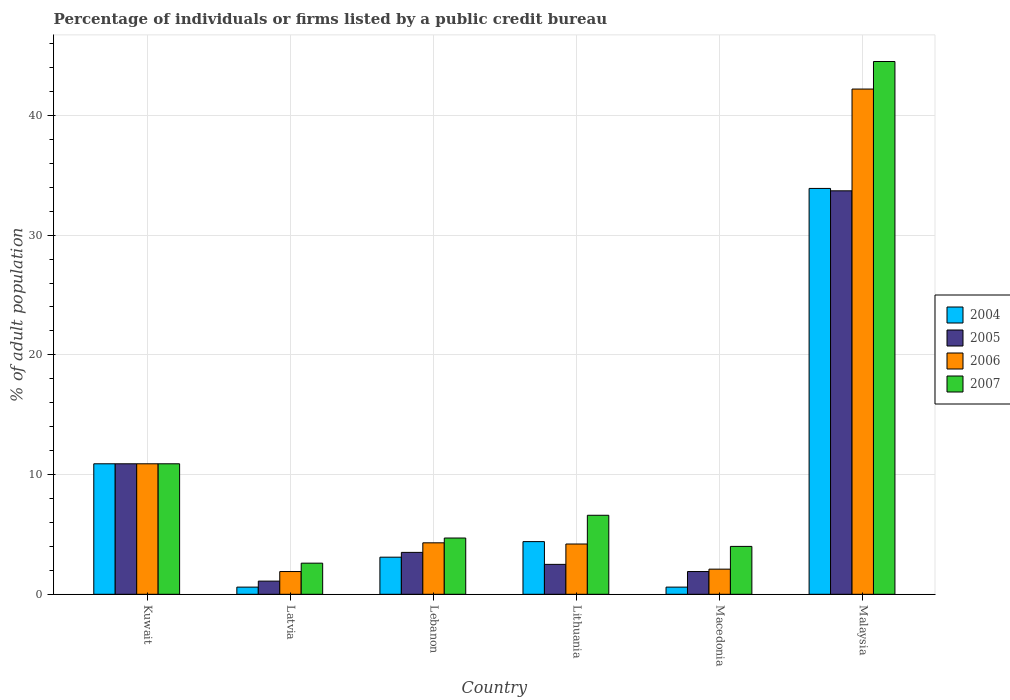How many different coloured bars are there?
Offer a very short reply. 4. What is the label of the 3rd group of bars from the left?
Keep it short and to the point. Lebanon. What is the percentage of population listed by a public credit bureau in 2007 in Kuwait?
Keep it short and to the point. 10.9. Across all countries, what is the maximum percentage of population listed by a public credit bureau in 2007?
Offer a very short reply. 44.5. In which country was the percentage of population listed by a public credit bureau in 2005 maximum?
Provide a short and direct response. Malaysia. In which country was the percentage of population listed by a public credit bureau in 2005 minimum?
Provide a succinct answer. Latvia. What is the total percentage of population listed by a public credit bureau in 2007 in the graph?
Provide a short and direct response. 73.3. What is the difference between the percentage of population listed by a public credit bureau in 2005 in Latvia and that in Macedonia?
Give a very brief answer. -0.8. What is the average percentage of population listed by a public credit bureau in 2004 per country?
Offer a terse response. 8.92. What is the difference between the percentage of population listed by a public credit bureau of/in 2004 and percentage of population listed by a public credit bureau of/in 2005 in Lithuania?
Provide a short and direct response. 1.9. What is the ratio of the percentage of population listed by a public credit bureau in 2007 in Latvia to that in Malaysia?
Give a very brief answer. 0.06. Is the difference between the percentage of population listed by a public credit bureau in 2004 in Lithuania and Macedonia greater than the difference between the percentage of population listed by a public credit bureau in 2005 in Lithuania and Macedonia?
Your answer should be very brief. Yes. What is the difference between the highest and the second highest percentage of population listed by a public credit bureau in 2007?
Provide a short and direct response. -33.6. What is the difference between the highest and the lowest percentage of population listed by a public credit bureau in 2006?
Your answer should be compact. 40.3. Is the sum of the percentage of population listed by a public credit bureau in 2004 in Latvia and Macedonia greater than the maximum percentage of population listed by a public credit bureau in 2007 across all countries?
Offer a terse response. No. Is it the case that in every country, the sum of the percentage of population listed by a public credit bureau in 2004 and percentage of population listed by a public credit bureau in 2006 is greater than the sum of percentage of population listed by a public credit bureau in 2007 and percentage of population listed by a public credit bureau in 2005?
Ensure brevity in your answer.  No. What does the 4th bar from the left in Malaysia represents?
Keep it short and to the point. 2007. Is it the case that in every country, the sum of the percentage of population listed by a public credit bureau in 2004 and percentage of population listed by a public credit bureau in 2006 is greater than the percentage of population listed by a public credit bureau in 2007?
Provide a succinct answer. No. How many bars are there?
Offer a very short reply. 24. How many countries are there in the graph?
Provide a succinct answer. 6. Are the values on the major ticks of Y-axis written in scientific E-notation?
Provide a short and direct response. No. How are the legend labels stacked?
Offer a very short reply. Vertical. What is the title of the graph?
Keep it short and to the point. Percentage of individuals or firms listed by a public credit bureau. Does "1987" appear as one of the legend labels in the graph?
Provide a succinct answer. No. What is the label or title of the Y-axis?
Your answer should be compact. % of adult population. What is the % of adult population of 2004 in Kuwait?
Give a very brief answer. 10.9. What is the % of adult population in 2005 in Kuwait?
Offer a terse response. 10.9. What is the % of adult population in 2007 in Kuwait?
Ensure brevity in your answer.  10.9. What is the % of adult population in 2004 in Latvia?
Give a very brief answer. 0.6. What is the % of adult population of 2006 in Latvia?
Ensure brevity in your answer.  1.9. What is the % of adult population of 2004 in Lebanon?
Make the answer very short. 3.1. What is the % of adult population in 2005 in Lithuania?
Keep it short and to the point. 2.5. What is the % of adult population of 2006 in Lithuania?
Your answer should be compact. 4.2. What is the % of adult population in 2004 in Macedonia?
Provide a short and direct response. 0.6. What is the % of adult population in 2007 in Macedonia?
Provide a short and direct response. 4. What is the % of adult population of 2004 in Malaysia?
Give a very brief answer. 33.9. What is the % of adult population in 2005 in Malaysia?
Your answer should be very brief. 33.7. What is the % of adult population in 2006 in Malaysia?
Make the answer very short. 42.2. What is the % of adult population of 2007 in Malaysia?
Ensure brevity in your answer.  44.5. Across all countries, what is the maximum % of adult population in 2004?
Make the answer very short. 33.9. Across all countries, what is the maximum % of adult population of 2005?
Offer a very short reply. 33.7. Across all countries, what is the maximum % of adult population in 2006?
Keep it short and to the point. 42.2. Across all countries, what is the maximum % of adult population of 2007?
Give a very brief answer. 44.5. Across all countries, what is the minimum % of adult population in 2005?
Provide a short and direct response. 1.1. Across all countries, what is the minimum % of adult population in 2006?
Your answer should be very brief. 1.9. What is the total % of adult population of 2004 in the graph?
Offer a very short reply. 53.5. What is the total % of adult population of 2005 in the graph?
Offer a very short reply. 53.6. What is the total % of adult population in 2006 in the graph?
Keep it short and to the point. 65.6. What is the total % of adult population of 2007 in the graph?
Give a very brief answer. 73.3. What is the difference between the % of adult population of 2006 in Kuwait and that in Latvia?
Offer a terse response. 9. What is the difference between the % of adult population of 2007 in Kuwait and that in Latvia?
Provide a short and direct response. 8.3. What is the difference between the % of adult population of 2007 in Kuwait and that in Lebanon?
Ensure brevity in your answer.  6.2. What is the difference between the % of adult population of 2005 in Kuwait and that in Lithuania?
Your response must be concise. 8.4. What is the difference between the % of adult population of 2007 in Kuwait and that in Lithuania?
Your answer should be compact. 4.3. What is the difference between the % of adult population in 2004 in Kuwait and that in Macedonia?
Give a very brief answer. 10.3. What is the difference between the % of adult population of 2006 in Kuwait and that in Macedonia?
Offer a very short reply. 8.8. What is the difference between the % of adult population in 2004 in Kuwait and that in Malaysia?
Ensure brevity in your answer.  -23. What is the difference between the % of adult population in 2005 in Kuwait and that in Malaysia?
Keep it short and to the point. -22.8. What is the difference between the % of adult population of 2006 in Kuwait and that in Malaysia?
Offer a very short reply. -31.3. What is the difference between the % of adult population in 2007 in Kuwait and that in Malaysia?
Your answer should be very brief. -33.6. What is the difference between the % of adult population of 2004 in Latvia and that in Lebanon?
Offer a terse response. -2.5. What is the difference between the % of adult population of 2005 in Latvia and that in Lebanon?
Provide a short and direct response. -2.4. What is the difference between the % of adult population in 2005 in Latvia and that in Lithuania?
Offer a very short reply. -1.4. What is the difference between the % of adult population of 2006 in Latvia and that in Lithuania?
Provide a succinct answer. -2.3. What is the difference between the % of adult population of 2007 in Latvia and that in Lithuania?
Ensure brevity in your answer.  -4. What is the difference between the % of adult population of 2004 in Latvia and that in Macedonia?
Your answer should be compact. 0. What is the difference between the % of adult population of 2005 in Latvia and that in Macedonia?
Offer a terse response. -0.8. What is the difference between the % of adult population in 2004 in Latvia and that in Malaysia?
Keep it short and to the point. -33.3. What is the difference between the % of adult population of 2005 in Latvia and that in Malaysia?
Make the answer very short. -32.6. What is the difference between the % of adult population in 2006 in Latvia and that in Malaysia?
Give a very brief answer. -40.3. What is the difference between the % of adult population in 2007 in Latvia and that in Malaysia?
Give a very brief answer. -41.9. What is the difference between the % of adult population of 2004 in Lebanon and that in Lithuania?
Provide a short and direct response. -1.3. What is the difference between the % of adult population in 2005 in Lebanon and that in Lithuania?
Offer a very short reply. 1. What is the difference between the % of adult population in 2004 in Lebanon and that in Macedonia?
Offer a terse response. 2.5. What is the difference between the % of adult population in 2006 in Lebanon and that in Macedonia?
Your response must be concise. 2.2. What is the difference between the % of adult population of 2007 in Lebanon and that in Macedonia?
Give a very brief answer. 0.7. What is the difference between the % of adult population in 2004 in Lebanon and that in Malaysia?
Ensure brevity in your answer.  -30.8. What is the difference between the % of adult population in 2005 in Lebanon and that in Malaysia?
Your response must be concise. -30.2. What is the difference between the % of adult population of 2006 in Lebanon and that in Malaysia?
Provide a succinct answer. -37.9. What is the difference between the % of adult population of 2007 in Lebanon and that in Malaysia?
Provide a succinct answer. -39.8. What is the difference between the % of adult population of 2005 in Lithuania and that in Macedonia?
Your response must be concise. 0.6. What is the difference between the % of adult population in 2004 in Lithuania and that in Malaysia?
Your response must be concise. -29.5. What is the difference between the % of adult population of 2005 in Lithuania and that in Malaysia?
Your answer should be compact. -31.2. What is the difference between the % of adult population in 2006 in Lithuania and that in Malaysia?
Ensure brevity in your answer.  -38. What is the difference between the % of adult population of 2007 in Lithuania and that in Malaysia?
Make the answer very short. -37.9. What is the difference between the % of adult population in 2004 in Macedonia and that in Malaysia?
Your answer should be very brief. -33.3. What is the difference between the % of adult population of 2005 in Macedonia and that in Malaysia?
Give a very brief answer. -31.8. What is the difference between the % of adult population of 2006 in Macedonia and that in Malaysia?
Provide a succinct answer. -40.1. What is the difference between the % of adult population of 2007 in Macedonia and that in Malaysia?
Give a very brief answer. -40.5. What is the difference between the % of adult population of 2004 in Kuwait and the % of adult population of 2005 in Latvia?
Provide a succinct answer. 9.8. What is the difference between the % of adult population in 2004 in Kuwait and the % of adult population in 2006 in Latvia?
Your answer should be compact. 9. What is the difference between the % of adult population of 2005 in Kuwait and the % of adult population of 2007 in Latvia?
Your response must be concise. 8.3. What is the difference between the % of adult population in 2004 in Kuwait and the % of adult population in 2005 in Lebanon?
Ensure brevity in your answer.  7.4. What is the difference between the % of adult population in 2005 in Kuwait and the % of adult population in 2006 in Lebanon?
Make the answer very short. 6.6. What is the difference between the % of adult population of 2005 in Kuwait and the % of adult population of 2007 in Lebanon?
Ensure brevity in your answer.  6.2. What is the difference between the % of adult population in 2006 in Kuwait and the % of adult population in 2007 in Lebanon?
Offer a very short reply. 6.2. What is the difference between the % of adult population of 2004 in Kuwait and the % of adult population of 2005 in Lithuania?
Offer a terse response. 8.4. What is the difference between the % of adult population of 2004 in Kuwait and the % of adult population of 2006 in Lithuania?
Ensure brevity in your answer.  6.7. What is the difference between the % of adult population of 2004 in Kuwait and the % of adult population of 2007 in Lithuania?
Give a very brief answer. 4.3. What is the difference between the % of adult population of 2005 in Kuwait and the % of adult population of 2006 in Lithuania?
Your answer should be compact. 6.7. What is the difference between the % of adult population of 2004 in Kuwait and the % of adult population of 2007 in Macedonia?
Offer a terse response. 6.9. What is the difference between the % of adult population of 2005 in Kuwait and the % of adult population of 2006 in Macedonia?
Ensure brevity in your answer.  8.8. What is the difference between the % of adult population in 2006 in Kuwait and the % of adult population in 2007 in Macedonia?
Provide a short and direct response. 6.9. What is the difference between the % of adult population of 2004 in Kuwait and the % of adult population of 2005 in Malaysia?
Give a very brief answer. -22.8. What is the difference between the % of adult population of 2004 in Kuwait and the % of adult population of 2006 in Malaysia?
Give a very brief answer. -31.3. What is the difference between the % of adult population of 2004 in Kuwait and the % of adult population of 2007 in Malaysia?
Your answer should be compact. -33.6. What is the difference between the % of adult population of 2005 in Kuwait and the % of adult population of 2006 in Malaysia?
Offer a very short reply. -31.3. What is the difference between the % of adult population in 2005 in Kuwait and the % of adult population in 2007 in Malaysia?
Offer a very short reply. -33.6. What is the difference between the % of adult population in 2006 in Kuwait and the % of adult population in 2007 in Malaysia?
Offer a terse response. -33.6. What is the difference between the % of adult population in 2004 in Latvia and the % of adult population in 2007 in Lebanon?
Your response must be concise. -4.1. What is the difference between the % of adult population in 2005 in Latvia and the % of adult population in 2006 in Lithuania?
Offer a terse response. -3.1. What is the difference between the % of adult population in 2005 in Latvia and the % of adult population in 2007 in Lithuania?
Ensure brevity in your answer.  -5.5. What is the difference between the % of adult population of 2004 in Latvia and the % of adult population of 2005 in Macedonia?
Make the answer very short. -1.3. What is the difference between the % of adult population of 2004 in Latvia and the % of adult population of 2007 in Macedonia?
Keep it short and to the point. -3.4. What is the difference between the % of adult population in 2006 in Latvia and the % of adult population in 2007 in Macedonia?
Offer a very short reply. -2.1. What is the difference between the % of adult population in 2004 in Latvia and the % of adult population in 2005 in Malaysia?
Give a very brief answer. -33.1. What is the difference between the % of adult population in 2004 in Latvia and the % of adult population in 2006 in Malaysia?
Keep it short and to the point. -41.6. What is the difference between the % of adult population in 2004 in Latvia and the % of adult population in 2007 in Malaysia?
Offer a terse response. -43.9. What is the difference between the % of adult population of 2005 in Latvia and the % of adult population of 2006 in Malaysia?
Give a very brief answer. -41.1. What is the difference between the % of adult population in 2005 in Latvia and the % of adult population in 2007 in Malaysia?
Provide a short and direct response. -43.4. What is the difference between the % of adult population of 2006 in Latvia and the % of adult population of 2007 in Malaysia?
Provide a succinct answer. -42.6. What is the difference between the % of adult population of 2004 in Lebanon and the % of adult population of 2005 in Lithuania?
Your answer should be compact. 0.6. What is the difference between the % of adult population in 2004 in Lebanon and the % of adult population in 2006 in Lithuania?
Your response must be concise. -1.1. What is the difference between the % of adult population in 2005 in Lebanon and the % of adult population in 2006 in Lithuania?
Your answer should be compact. -0.7. What is the difference between the % of adult population of 2005 in Lebanon and the % of adult population of 2007 in Lithuania?
Give a very brief answer. -3.1. What is the difference between the % of adult population of 2004 in Lebanon and the % of adult population of 2006 in Macedonia?
Ensure brevity in your answer.  1. What is the difference between the % of adult population of 2005 in Lebanon and the % of adult population of 2006 in Macedonia?
Provide a short and direct response. 1.4. What is the difference between the % of adult population of 2005 in Lebanon and the % of adult population of 2007 in Macedonia?
Provide a succinct answer. -0.5. What is the difference between the % of adult population of 2006 in Lebanon and the % of adult population of 2007 in Macedonia?
Ensure brevity in your answer.  0.3. What is the difference between the % of adult population of 2004 in Lebanon and the % of adult population of 2005 in Malaysia?
Offer a terse response. -30.6. What is the difference between the % of adult population in 2004 in Lebanon and the % of adult population in 2006 in Malaysia?
Your answer should be very brief. -39.1. What is the difference between the % of adult population in 2004 in Lebanon and the % of adult population in 2007 in Malaysia?
Make the answer very short. -41.4. What is the difference between the % of adult population of 2005 in Lebanon and the % of adult population of 2006 in Malaysia?
Your answer should be compact. -38.7. What is the difference between the % of adult population of 2005 in Lebanon and the % of adult population of 2007 in Malaysia?
Your answer should be very brief. -41. What is the difference between the % of adult population of 2006 in Lebanon and the % of adult population of 2007 in Malaysia?
Provide a short and direct response. -40.2. What is the difference between the % of adult population in 2004 in Lithuania and the % of adult population in 2006 in Macedonia?
Your answer should be very brief. 2.3. What is the difference between the % of adult population of 2005 in Lithuania and the % of adult population of 2007 in Macedonia?
Ensure brevity in your answer.  -1.5. What is the difference between the % of adult population in 2006 in Lithuania and the % of adult population in 2007 in Macedonia?
Ensure brevity in your answer.  0.2. What is the difference between the % of adult population in 2004 in Lithuania and the % of adult population in 2005 in Malaysia?
Your response must be concise. -29.3. What is the difference between the % of adult population in 2004 in Lithuania and the % of adult population in 2006 in Malaysia?
Make the answer very short. -37.8. What is the difference between the % of adult population in 2004 in Lithuania and the % of adult population in 2007 in Malaysia?
Give a very brief answer. -40.1. What is the difference between the % of adult population of 2005 in Lithuania and the % of adult population of 2006 in Malaysia?
Offer a very short reply. -39.7. What is the difference between the % of adult population in 2005 in Lithuania and the % of adult population in 2007 in Malaysia?
Provide a short and direct response. -42. What is the difference between the % of adult population in 2006 in Lithuania and the % of adult population in 2007 in Malaysia?
Offer a very short reply. -40.3. What is the difference between the % of adult population in 2004 in Macedonia and the % of adult population in 2005 in Malaysia?
Make the answer very short. -33.1. What is the difference between the % of adult population in 2004 in Macedonia and the % of adult population in 2006 in Malaysia?
Give a very brief answer. -41.6. What is the difference between the % of adult population of 2004 in Macedonia and the % of adult population of 2007 in Malaysia?
Give a very brief answer. -43.9. What is the difference between the % of adult population of 2005 in Macedonia and the % of adult population of 2006 in Malaysia?
Offer a very short reply. -40.3. What is the difference between the % of adult population of 2005 in Macedonia and the % of adult population of 2007 in Malaysia?
Provide a succinct answer. -42.6. What is the difference between the % of adult population in 2006 in Macedonia and the % of adult population in 2007 in Malaysia?
Ensure brevity in your answer.  -42.4. What is the average % of adult population of 2004 per country?
Give a very brief answer. 8.92. What is the average % of adult population in 2005 per country?
Provide a short and direct response. 8.93. What is the average % of adult population of 2006 per country?
Your answer should be very brief. 10.93. What is the average % of adult population of 2007 per country?
Provide a short and direct response. 12.22. What is the difference between the % of adult population of 2004 and % of adult population of 2005 in Kuwait?
Your answer should be compact. 0. What is the difference between the % of adult population of 2005 and % of adult population of 2007 in Kuwait?
Ensure brevity in your answer.  0. What is the difference between the % of adult population of 2006 and % of adult population of 2007 in Kuwait?
Offer a terse response. 0. What is the difference between the % of adult population in 2004 and % of adult population in 2007 in Latvia?
Make the answer very short. -2. What is the difference between the % of adult population in 2005 and % of adult population in 2007 in Latvia?
Offer a very short reply. -1.5. What is the difference between the % of adult population in 2004 and % of adult population in 2005 in Lebanon?
Your response must be concise. -0.4. What is the difference between the % of adult population of 2004 and % of adult population of 2006 in Lebanon?
Provide a succinct answer. -1.2. What is the difference between the % of adult population of 2004 and % of adult population of 2007 in Lebanon?
Keep it short and to the point. -1.6. What is the difference between the % of adult population of 2005 and % of adult population of 2006 in Lebanon?
Your answer should be compact. -0.8. What is the difference between the % of adult population of 2004 and % of adult population of 2007 in Lithuania?
Your response must be concise. -2.2. What is the difference between the % of adult population of 2005 and % of adult population of 2006 in Lithuania?
Give a very brief answer. -1.7. What is the difference between the % of adult population in 2006 and % of adult population in 2007 in Lithuania?
Make the answer very short. -2.4. What is the difference between the % of adult population in 2004 and % of adult population in 2005 in Macedonia?
Offer a terse response. -1.3. What is the difference between the % of adult population in 2004 and % of adult population in 2006 in Macedonia?
Your answer should be very brief. -1.5. What is the difference between the % of adult population in 2005 and % of adult population in 2006 in Macedonia?
Keep it short and to the point. -0.2. What is the difference between the % of adult population in 2006 and % of adult population in 2007 in Macedonia?
Offer a terse response. -1.9. What is the difference between the % of adult population of 2004 and % of adult population of 2007 in Malaysia?
Make the answer very short. -10.6. What is the difference between the % of adult population of 2006 and % of adult population of 2007 in Malaysia?
Your answer should be compact. -2.3. What is the ratio of the % of adult population of 2004 in Kuwait to that in Latvia?
Offer a very short reply. 18.17. What is the ratio of the % of adult population in 2005 in Kuwait to that in Latvia?
Your answer should be compact. 9.91. What is the ratio of the % of adult population of 2006 in Kuwait to that in Latvia?
Your answer should be very brief. 5.74. What is the ratio of the % of adult population in 2007 in Kuwait to that in Latvia?
Your answer should be compact. 4.19. What is the ratio of the % of adult population in 2004 in Kuwait to that in Lebanon?
Offer a very short reply. 3.52. What is the ratio of the % of adult population in 2005 in Kuwait to that in Lebanon?
Your answer should be very brief. 3.11. What is the ratio of the % of adult population of 2006 in Kuwait to that in Lebanon?
Offer a very short reply. 2.53. What is the ratio of the % of adult population in 2007 in Kuwait to that in Lebanon?
Offer a terse response. 2.32. What is the ratio of the % of adult population in 2004 in Kuwait to that in Lithuania?
Provide a short and direct response. 2.48. What is the ratio of the % of adult population in 2005 in Kuwait to that in Lithuania?
Give a very brief answer. 4.36. What is the ratio of the % of adult population in 2006 in Kuwait to that in Lithuania?
Ensure brevity in your answer.  2.6. What is the ratio of the % of adult population in 2007 in Kuwait to that in Lithuania?
Provide a succinct answer. 1.65. What is the ratio of the % of adult population of 2004 in Kuwait to that in Macedonia?
Make the answer very short. 18.17. What is the ratio of the % of adult population in 2005 in Kuwait to that in Macedonia?
Your answer should be very brief. 5.74. What is the ratio of the % of adult population in 2006 in Kuwait to that in Macedonia?
Provide a succinct answer. 5.19. What is the ratio of the % of adult population of 2007 in Kuwait to that in Macedonia?
Provide a short and direct response. 2.73. What is the ratio of the % of adult population of 2004 in Kuwait to that in Malaysia?
Provide a short and direct response. 0.32. What is the ratio of the % of adult population of 2005 in Kuwait to that in Malaysia?
Provide a succinct answer. 0.32. What is the ratio of the % of adult population of 2006 in Kuwait to that in Malaysia?
Give a very brief answer. 0.26. What is the ratio of the % of adult population in 2007 in Kuwait to that in Malaysia?
Keep it short and to the point. 0.24. What is the ratio of the % of adult population of 2004 in Latvia to that in Lebanon?
Your answer should be very brief. 0.19. What is the ratio of the % of adult population in 2005 in Latvia to that in Lebanon?
Keep it short and to the point. 0.31. What is the ratio of the % of adult population in 2006 in Latvia to that in Lebanon?
Keep it short and to the point. 0.44. What is the ratio of the % of adult population of 2007 in Latvia to that in Lebanon?
Offer a very short reply. 0.55. What is the ratio of the % of adult population in 2004 in Latvia to that in Lithuania?
Provide a short and direct response. 0.14. What is the ratio of the % of adult population of 2005 in Latvia to that in Lithuania?
Make the answer very short. 0.44. What is the ratio of the % of adult population in 2006 in Latvia to that in Lithuania?
Provide a short and direct response. 0.45. What is the ratio of the % of adult population in 2007 in Latvia to that in Lithuania?
Offer a terse response. 0.39. What is the ratio of the % of adult population of 2004 in Latvia to that in Macedonia?
Provide a short and direct response. 1. What is the ratio of the % of adult population in 2005 in Latvia to that in Macedonia?
Your response must be concise. 0.58. What is the ratio of the % of adult population of 2006 in Latvia to that in Macedonia?
Give a very brief answer. 0.9. What is the ratio of the % of adult population in 2007 in Latvia to that in Macedonia?
Your answer should be very brief. 0.65. What is the ratio of the % of adult population of 2004 in Latvia to that in Malaysia?
Your answer should be compact. 0.02. What is the ratio of the % of adult population in 2005 in Latvia to that in Malaysia?
Your answer should be very brief. 0.03. What is the ratio of the % of adult population of 2006 in Latvia to that in Malaysia?
Your answer should be very brief. 0.04. What is the ratio of the % of adult population of 2007 in Latvia to that in Malaysia?
Give a very brief answer. 0.06. What is the ratio of the % of adult population of 2004 in Lebanon to that in Lithuania?
Offer a terse response. 0.7. What is the ratio of the % of adult population of 2006 in Lebanon to that in Lithuania?
Your answer should be compact. 1.02. What is the ratio of the % of adult population of 2007 in Lebanon to that in Lithuania?
Make the answer very short. 0.71. What is the ratio of the % of adult population of 2004 in Lebanon to that in Macedonia?
Your response must be concise. 5.17. What is the ratio of the % of adult population of 2005 in Lebanon to that in Macedonia?
Offer a terse response. 1.84. What is the ratio of the % of adult population in 2006 in Lebanon to that in Macedonia?
Ensure brevity in your answer.  2.05. What is the ratio of the % of adult population of 2007 in Lebanon to that in Macedonia?
Provide a succinct answer. 1.18. What is the ratio of the % of adult population of 2004 in Lebanon to that in Malaysia?
Make the answer very short. 0.09. What is the ratio of the % of adult population of 2005 in Lebanon to that in Malaysia?
Keep it short and to the point. 0.1. What is the ratio of the % of adult population in 2006 in Lebanon to that in Malaysia?
Give a very brief answer. 0.1. What is the ratio of the % of adult population of 2007 in Lebanon to that in Malaysia?
Make the answer very short. 0.11. What is the ratio of the % of adult population of 2004 in Lithuania to that in Macedonia?
Offer a terse response. 7.33. What is the ratio of the % of adult population in 2005 in Lithuania to that in Macedonia?
Offer a terse response. 1.32. What is the ratio of the % of adult population of 2007 in Lithuania to that in Macedonia?
Your answer should be compact. 1.65. What is the ratio of the % of adult population in 2004 in Lithuania to that in Malaysia?
Your response must be concise. 0.13. What is the ratio of the % of adult population of 2005 in Lithuania to that in Malaysia?
Give a very brief answer. 0.07. What is the ratio of the % of adult population of 2006 in Lithuania to that in Malaysia?
Your answer should be very brief. 0.1. What is the ratio of the % of adult population of 2007 in Lithuania to that in Malaysia?
Offer a terse response. 0.15. What is the ratio of the % of adult population in 2004 in Macedonia to that in Malaysia?
Offer a terse response. 0.02. What is the ratio of the % of adult population of 2005 in Macedonia to that in Malaysia?
Ensure brevity in your answer.  0.06. What is the ratio of the % of adult population of 2006 in Macedonia to that in Malaysia?
Provide a short and direct response. 0.05. What is the ratio of the % of adult population in 2007 in Macedonia to that in Malaysia?
Your answer should be compact. 0.09. What is the difference between the highest and the second highest % of adult population of 2005?
Ensure brevity in your answer.  22.8. What is the difference between the highest and the second highest % of adult population of 2006?
Make the answer very short. 31.3. What is the difference between the highest and the second highest % of adult population in 2007?
Keep it short and to the point. 33.6. What is the difference between the highest and the lowest % of adult population of 2004?
Ensure brevity in your answer.  33.3. What is the difference between the highest and the lowest % of adult population of 2005?
Your response must be concise. 32.6. What is the difference between the highest and the lowest % of adult population of 2006?
Your answer should be compact. 40.3. What is the difference between the highest and the lowest % of adult population in 2007?
Give a very brief answer. 41.9. 